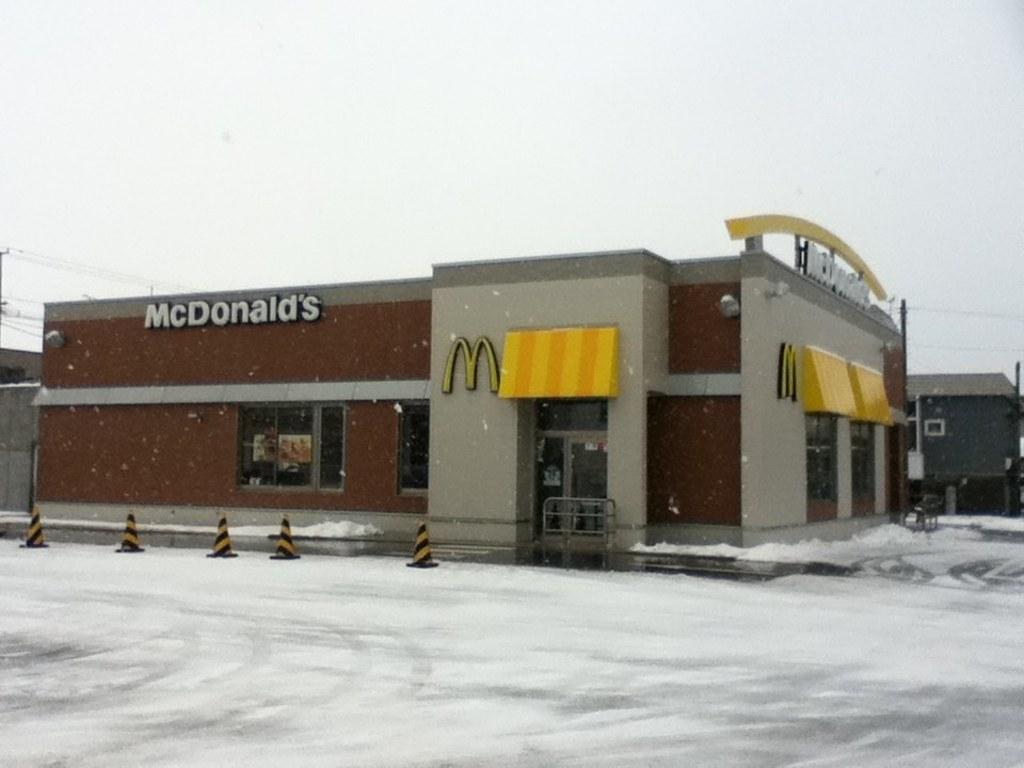Can you describe this image briefly? In this picture we can see a place in front of which the road is covered with ice. 